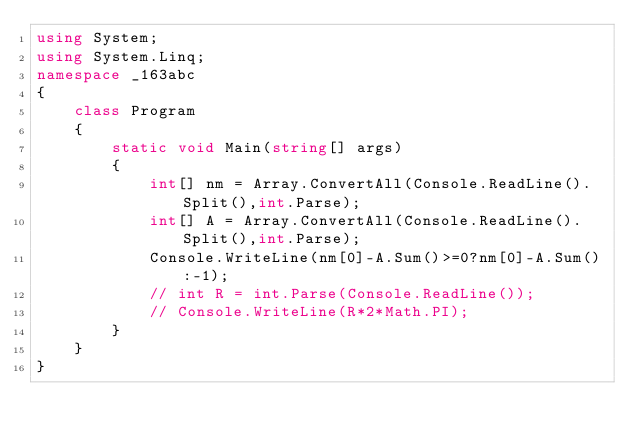Convert code to text. <code><loc_0><loc_0><loc_500><loc_500><_C#_>using System;
using System.Linq;
namespace _163abc
{
    class Program
    {
        static void Main(string[] args)
        {
            int[] nm = Array.ConvertAll(Console.ReadLine().Split(),int.Parse);
            int[] A = Array.ConvertAll(Console.ReadLine().Split(),int.Parse);
            Console.WriteLine(nm[0]-A.Sum()>=0?nm[0]-A.Sum():-1);
            // int R = int.Parse(Console.ReadLine());
            // Console.WriteLine(R*2*Math.PI);
        }
    }
}</code> 